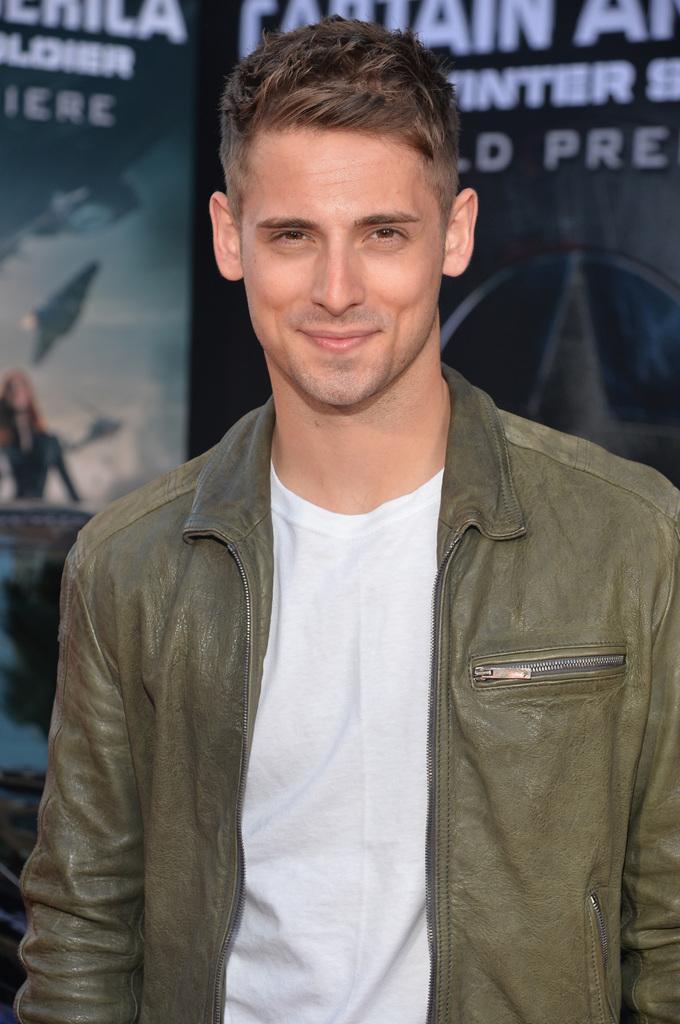Can you describe this image briefly? There is one man standing and wearing a jacket as we can see in the middle of this image. We can see a wall poster in the background. 